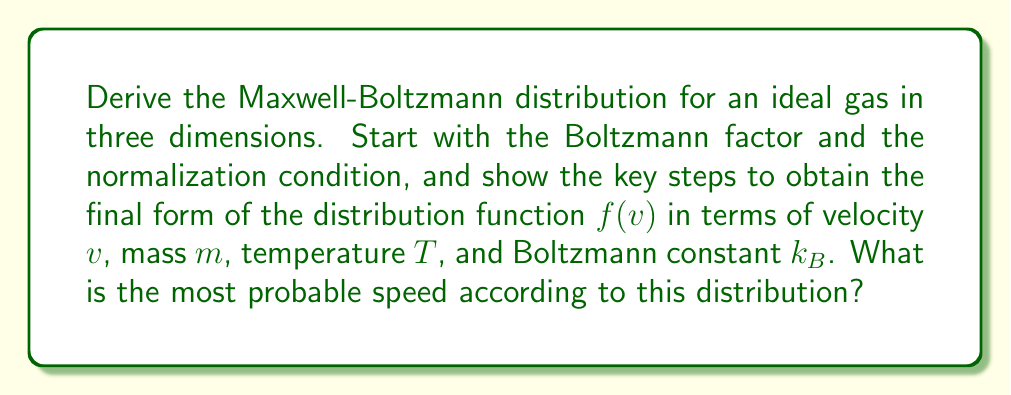Solve this math problem. Let's derive the Maxwell-Boltzmann distribution step-by-step:

1) We start with the Boltzmann factor, which gives the probability of a particle having energy $E$:

   $P(E) \propto e^{-E/k_BT}$

2) For an ideal gas, the energy is purely kinetic:

   $E = \frac{1}{2}mv^2$

3) Substituting this into the Boltzmann factor:

   $f(v) \propto e^{-mv^2/2k_BT}$

4) To get the full distribution, we need to normalize this and account for the three-dimensional nature of velocity. The normalization condition is:

   $\int_0^\infty 4\pi v^2 f(v) dv = 1$

   The $4\pi v^2$ term comes from the volume element in spherical coordinates.

5) Let's assume the full form of $f(v)$ is:

   $f(v) = A v^2 e^{-mv^2/2k_BT}$

   where $A$ is a normalization constant.

6) Substituting this into the normalization condition:

   $\int_0^\infty 4\pi A v^4 e^{-mv^2/2k_BT} dv = 1$

7) This integral can be solved using the substitution $u = mv^2/2k_BT$. After solving, we get:

   $A = (\frac{m}{2\pi k_BT})^{3/2}$

8) Therefore, the full Maxwell-Boltzmann distribution is:

   $f(v) = 4\pi (\frac{m}{2\pi k_BT})^{3/2} v^2 e^{-mv^2/2k_BT}$

9) To find the most probable speed, we differentiate $f(v)$ with respect to $v$ and set it to zero:

   $\frac{df}{dv} = 4\pi (\frac{m}{2\pi k_BT})^{3/2} [2v e^{-mv^2/2k_BT} - v^3 \frac{m}{k_BT} e^{-mv^2/2k_BT}] = 0$

10) Solving this equation gives us the most probable speed:

    $v_p = \sqrt{\frac{2k_BT}{m}}$
Answer: $f(v) = 4\pi (\frac{m}{2\pi k_BT})^{3/2} v^2 e^{-mv^2/2k_BT}$; Most probable speed: $v_p = \sqrt{\frac{2k_BT}{m}}$ 